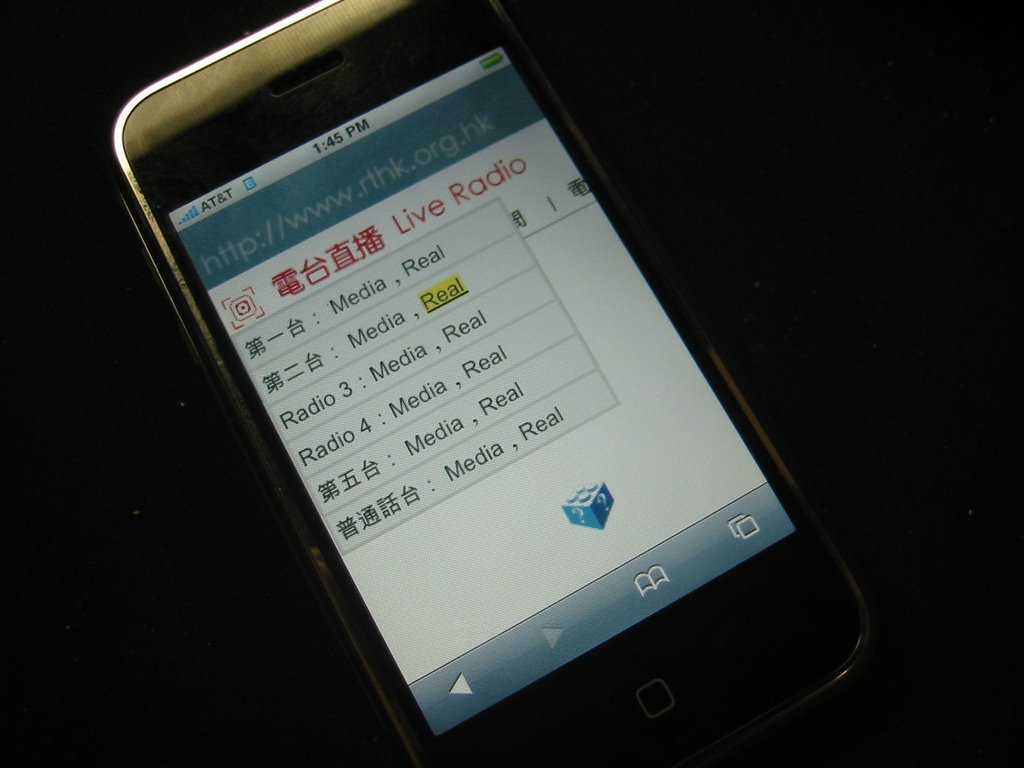What are the implications of using a bilingual interface in apps like the one shown, based on its user interface? Bilingual interfaces, such as the one shown on the smartphone, help cater to a diverse user base, improving accessibility and user engagement by providing content in languages familiar to broader audiences. This can be especially effective in regions with high linguistic diversity. 